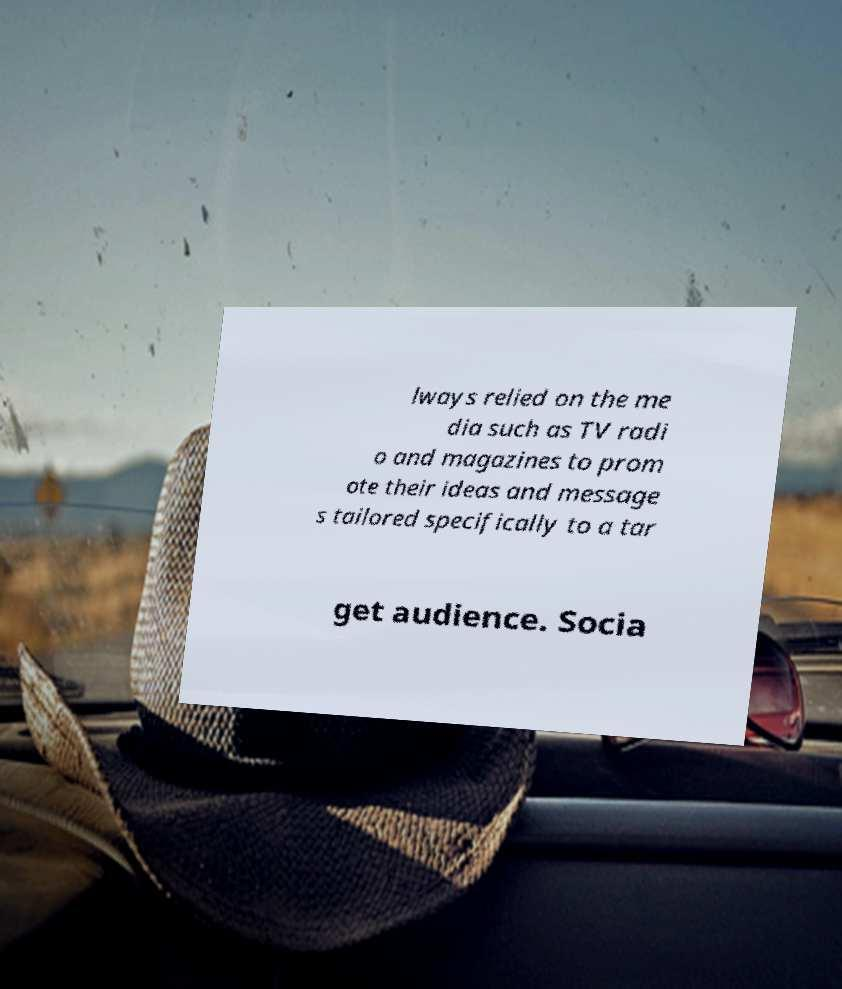Please identify and transcribe the text found in this image. lways relied on the me dia such as TV radi o and magazines to prom ote their ideas and message s tailored specifically to a tar get audience. Socia 